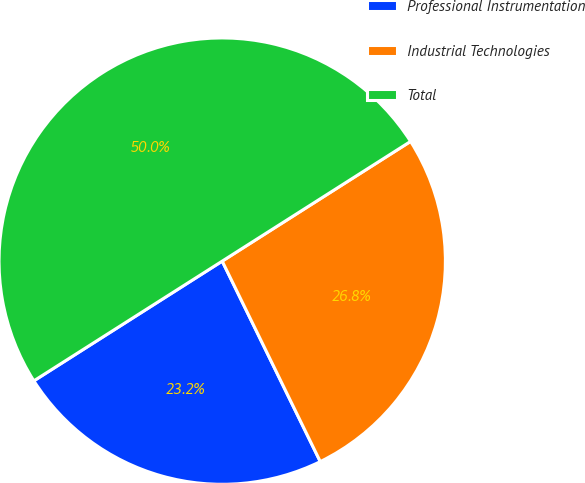Convert chart to OTSL. <chart><loc_0><loc_0><loc_500><loc_500><pie_chart><fcel>Professional Instrumentation<fcel>Industrial Technologies<fcel>Total<nl><fcel>23.23%<fcel>26.77%<fcel>50.0%<nl></chart> 